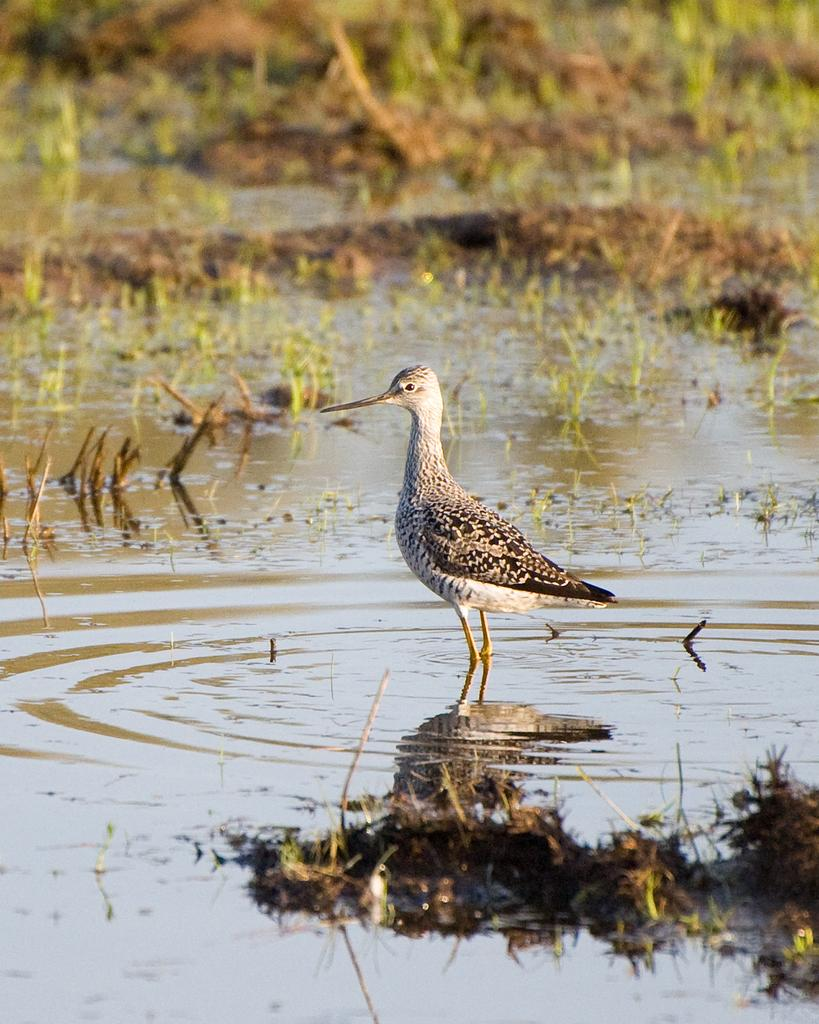What type of animal can be seen in the image? There is a bird in the image. Where is the bird located in the image? The bird is standing in the water. What type of vegetation is visible in the background of the image? There is grass visible in the background of the image. How would you describe the background of the image? The background of the image is blurred. What type of error message is displayed on the bird's beak in the image? There is no error message present on the bird's beak in the image. Can you tell me how many locks are visible on the bird's wings in the image? There are no locks visible on the bird's wings in the image. 